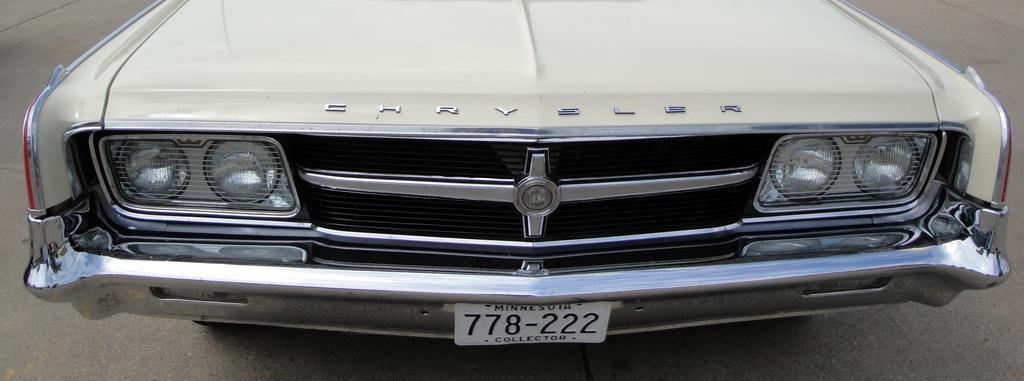How would you summarize this image in a sentence or two? In this image we can see a car on the road. 